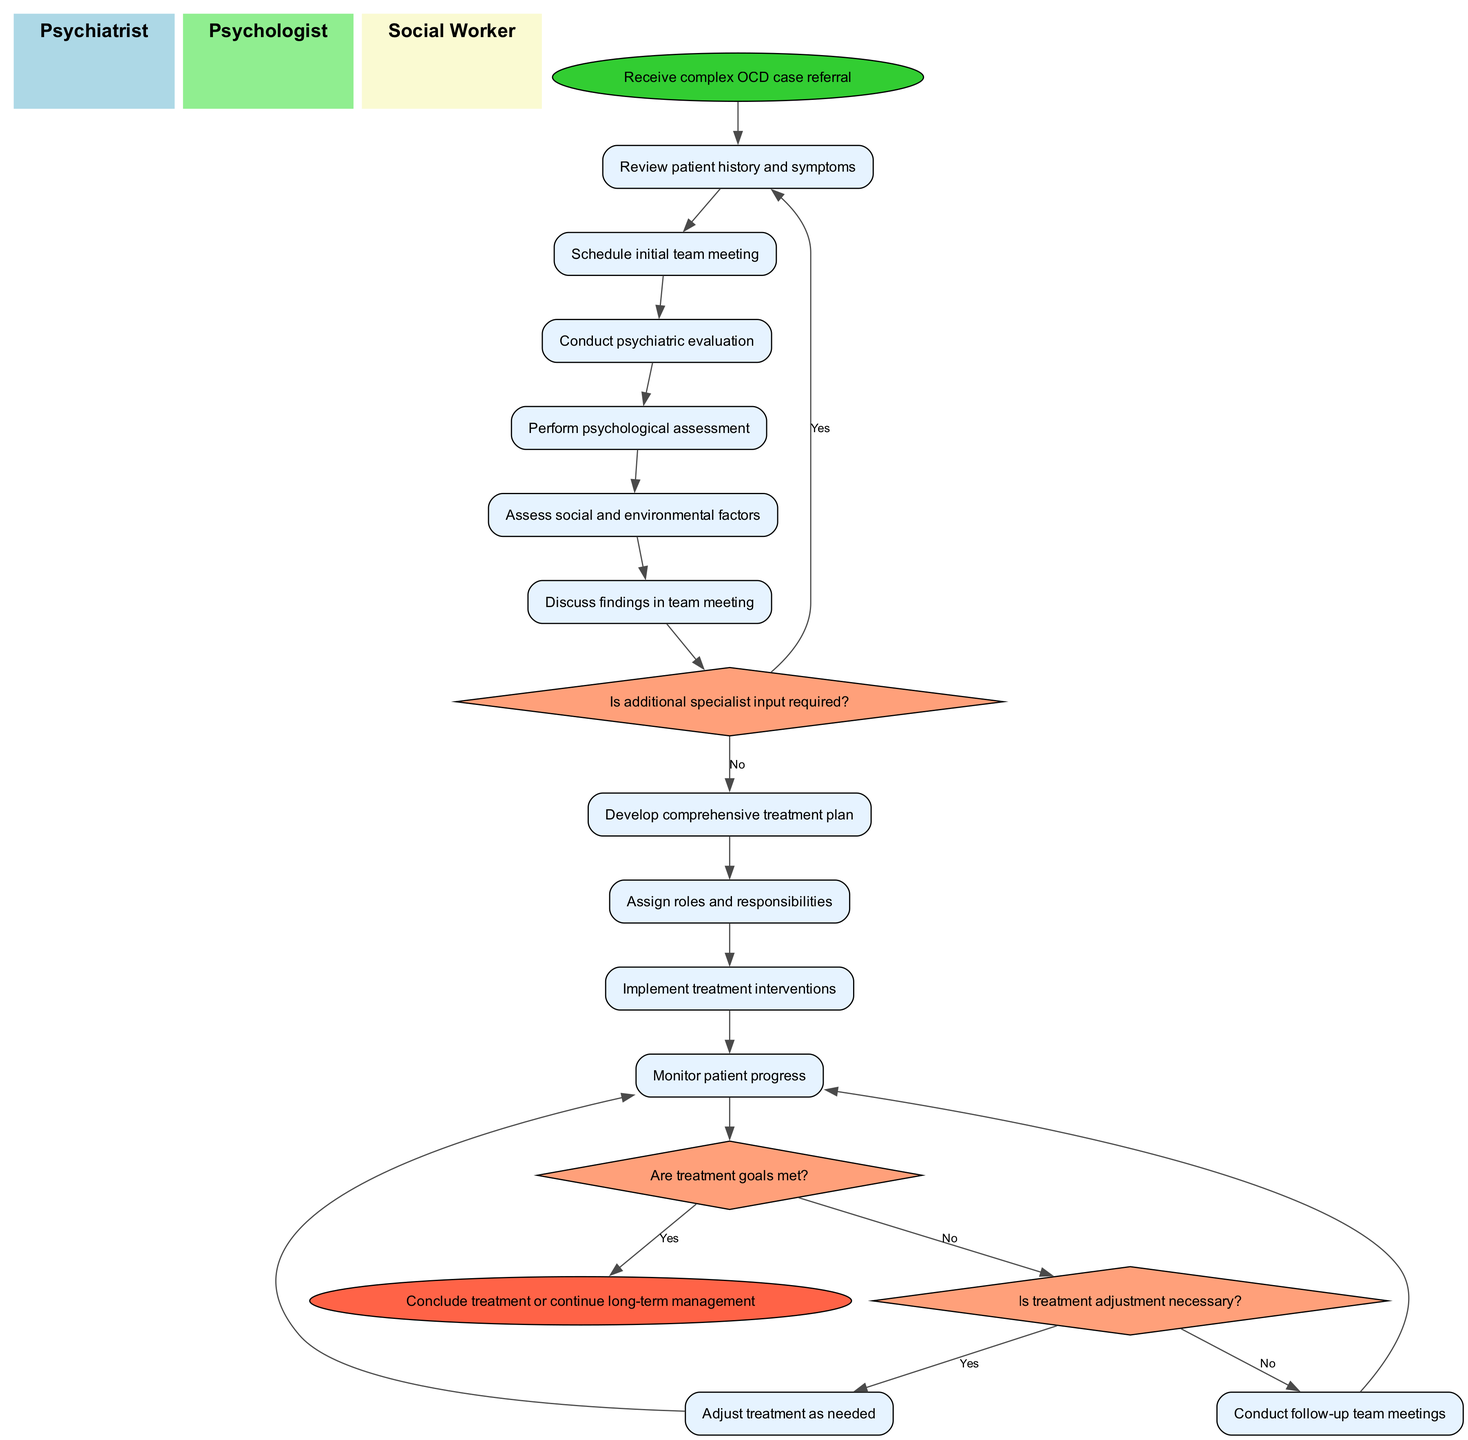What is the initial node in the diagram? The initial node represents the starting point of the process, which is "Receive complex OCD case referral." This is explicitly stated in the data provided.
Answer: Receive complex OCD case referral How many activities are listed in the diagram? The diagram lists activities that are part of the process. There are a total of 11 activities specified in the "activities" list in the data.
Answer: 11 What decision follows the "Discuss findings in team meeting" activity? After the "Discuss findings in team meeting" activity, the diagram shows a decision node labeled "Is additional specialist input required?" This reflects a point where the team must assess if further expertise is needed.
Answer: Is additional specialist input required? Which team member is responsible for conducting the psychiatric evaluation? The activity "Conduct psychiatric evaluation" is typically associated with the psychiatrist within the interdisciplinary team. This activity is placed under the psychiatrist swimlane in the diagram.
Answer: Psychiatrist What happens if the treatment goals are not met? If the treatment goals are not met, the flow diagram leads to the decision "Is treatment adjustment necessary?" indicating a further evaluation of the treatment plan is required. Subsequently, it leads to either an adjustment of treatment or the continuation of monitoring.
Answer: Is treatment adjustment necessary? What is the endpoint of the diagram? The endpoint signifies the conclusion of the process, which is explicitly labeled as "Conclude treatment or continue long-term management." This indicates the final outcome of the treatment approach.
Answer: Conclude treatment or continue long-term management How does the team decide if additional specialist input is needed? Following the "Discuss findings in team meeting" activity, the team faces the decision node "Is additional specialist input required?" Depending on the outcomes of the discussions, they choose to either repeat the earlier activities or proceed to develop a treatment plan, which indicates a collaborative decision-making process.
Answer: Is additional specialist input required? What is the purpose of the "Conduct follow-up team meetings" activity? The purpose of "Conduct follow-up team meetings" is to evaluate patient progress after treatment interventions have been implemented. This allows the team to make informed decisions about ongoing treatment plans based on the patient's response.
Answer: Evaluate patient progress How many decision nodes are in the diagram? There are three decision nodes depicted in the diagram, each representing critical points where the team assesses different aspects of the treatment plan and patient progress, based on the decisions described in the data.
Answer: 3 